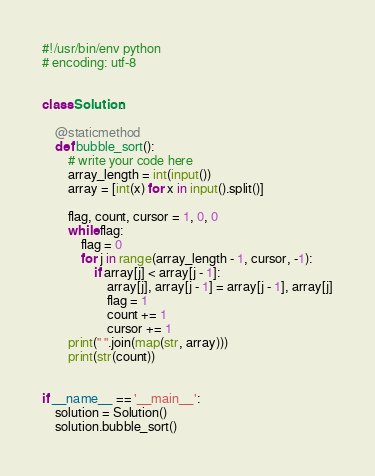Convert code to text. <code><loc_0><loc_0><loc_500><loc_500><_Python_>#!/usr/bin/env python
# encoding: utf-8


class Solution:

    @staticmethod
    def bubble_sort():
        # write your code here
        array_length = int(input())
        array = [int(x) for x in input().split()]

        flag, count, cursor = 1, 0, 0
        while flag:
            flag = 0
            for j in range(array_length - 1, cursor, -1):
                if array[j] < array[j - 1]:
                    array[j], array[j - 1] = array[j - 1], array[j]
                    flag = 1
                    count += 1
                    cursor += 1
        print(" ".join(map(str, array)))
        print(str(count))


if __name__ == '__main__':
    solution = Solution()
    solution.bubble_sort()</code> 